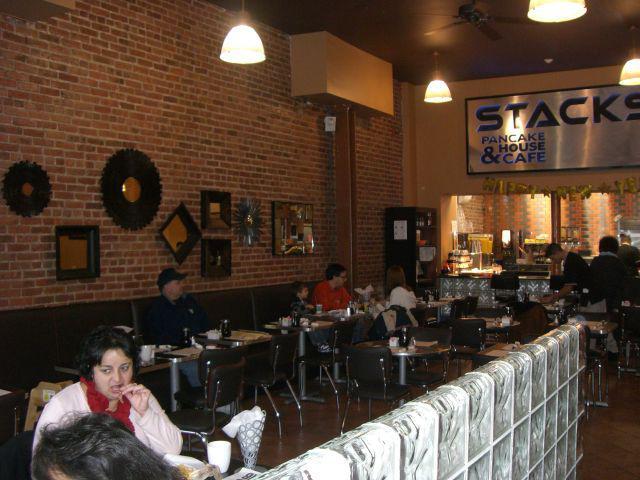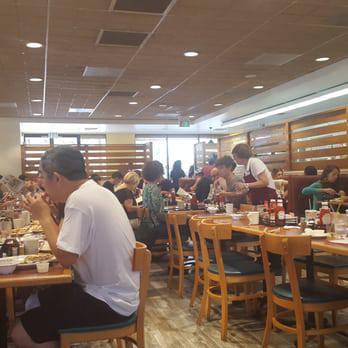The first image is the image on the left, the second image is the image on the right. For the images shown, is this caption "At least one of the images includes stained wooden beams on the ceiling." true? Answer yes or no. No. The first image is the image on the left, the second image is the image on the right. Considering the images on both sides, is "Someone is reading the menu board." valid? Answer yes or no. No. 